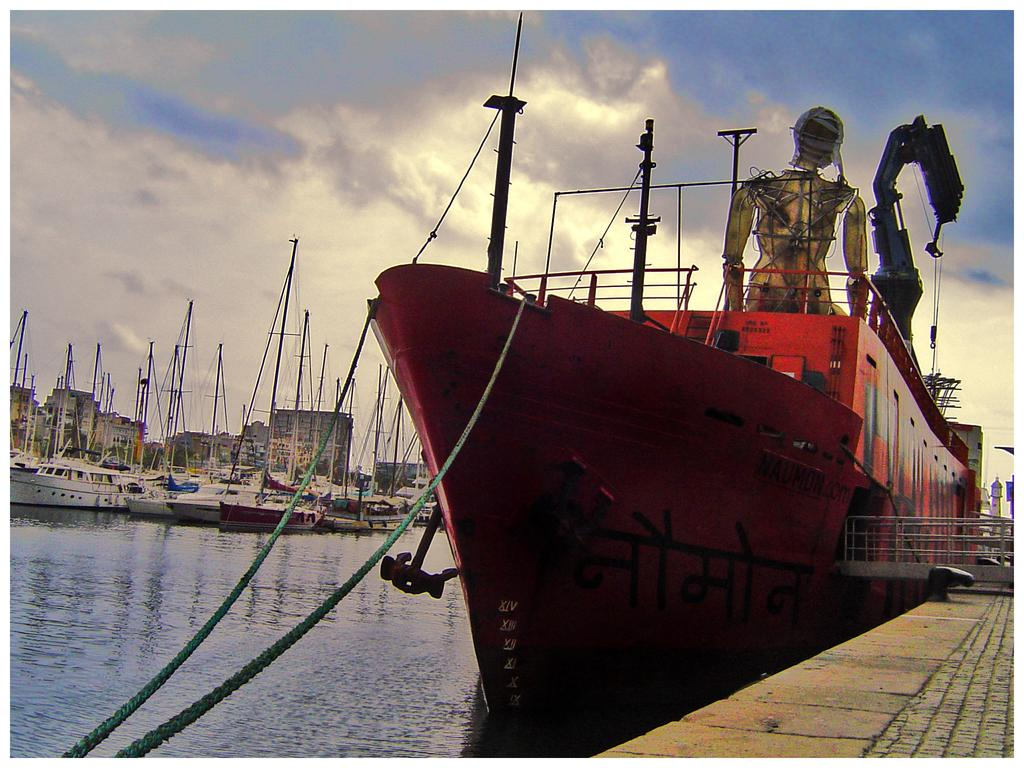What is depicted in the image? There are boats in the image. What is the boats' relationship with the water? The boats are floating on the water. What can be seen in the sky in the image? There are clouds visible in the sky. What type of silk is being traded between the boats in the image? There is no silk or trade activity depicted in the image; it only shows boats floating on the water and clouds in the sky. 